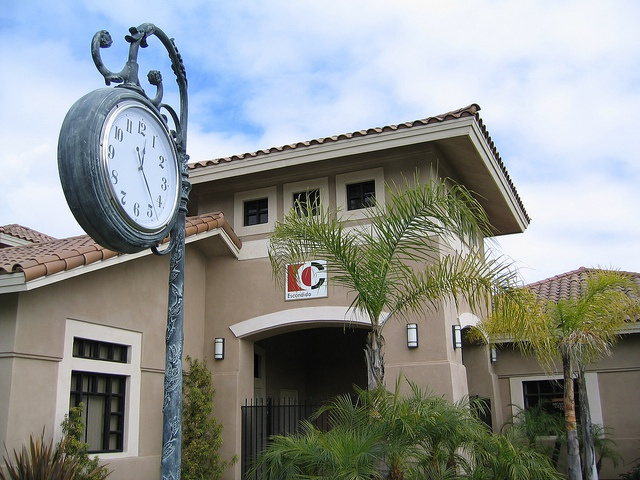Describe the objects in this image and their specific colors. I can see a clock in lightblue, lavender, black, and gray tones in this image. 